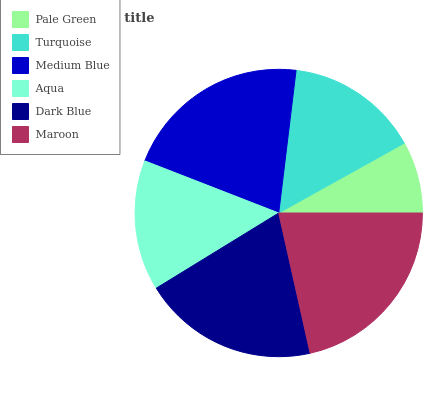Is Pale Green the minimum?
Answer yes or no. Yes. Is Maroon the maximum?
Answer yes or no. Yes. Is Turquoise the minimum?
Answer yes or no. No. Is Turquoise the maximum?
Answer yes or no. No. Is Turquoise greater than Pale Green?
Answer yes or no. Yes. Is Pale Green less than Turquoise?
Answer yes or no. Yes. Is Pale Green greater than Turquoise?
Answer yes or no. No. Is Turquoise less than Pale Green?
Answer yes or no. No. Is Dark Blue the high median?
Answer yes or no. Yes. Is Turquoise the low median?
Answer yes or no. Yes. Is Medium Blue the high median?
Answer yes or no. No. Is Maroon the low median?
Answer yes or no. No. 